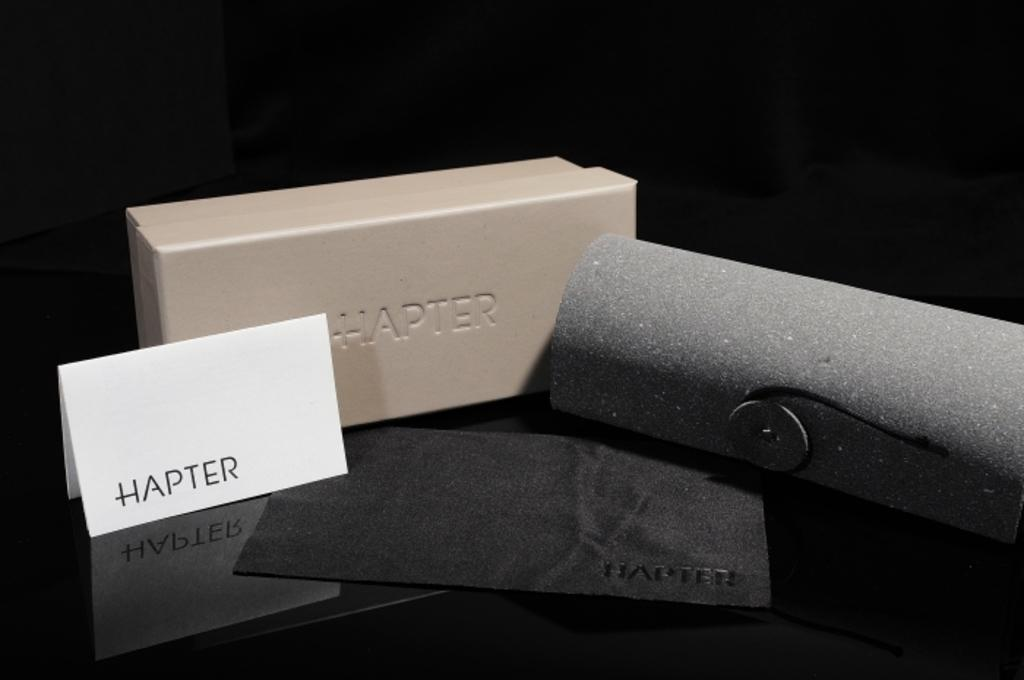<image>
Relay a brief, clear account of the picture shown. A display and a box from a company called Hapter 